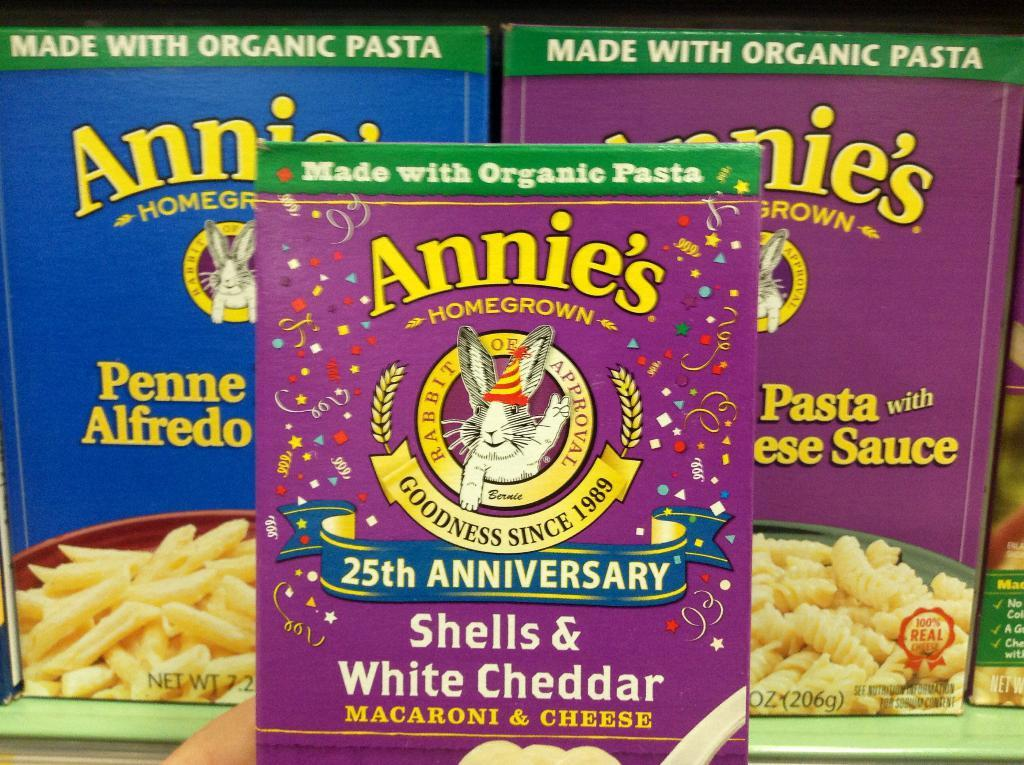What type of items are visible in the image? There are food packets in the image. Where are the food packets located? The food packets are on a table. What does your sister say about the food packets on the page? There is no mention of a sister or a page in the image, so it is not possible to answer that question. 